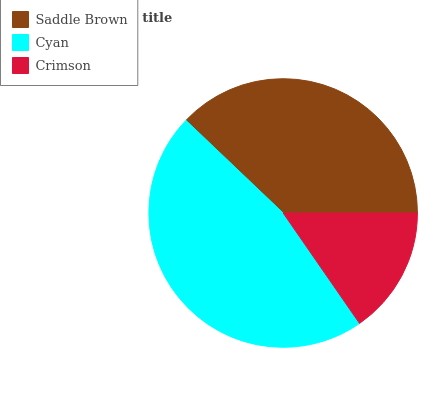Is Crimson the minimum?
Answer yes or no. Yes. Is Cyan the maximum?
Answer yes or no. Yes. Is Cyan the minimum?
Answer yes or no. No. Is Crimson the maximum?
Answer yes or no. No. Is Cyan greater than Crimson?
Answer yes or no. Yes. Is Crimson less than Cyan?
Answer yes or no. Yes. Is Crimson greater than Cyan?
Answer yes or no. No. Is Cyan less than Crimson?
Answer yes or no. No. Is Saddle Brown the high median?
Answer yes or no. Yes. Is Saddle Brown the low median?
Answer yes or no. Yes. Is Crimson the high median?
Answer yes or no. No. Is Crimson the low median?
Answer yes or no. No. 